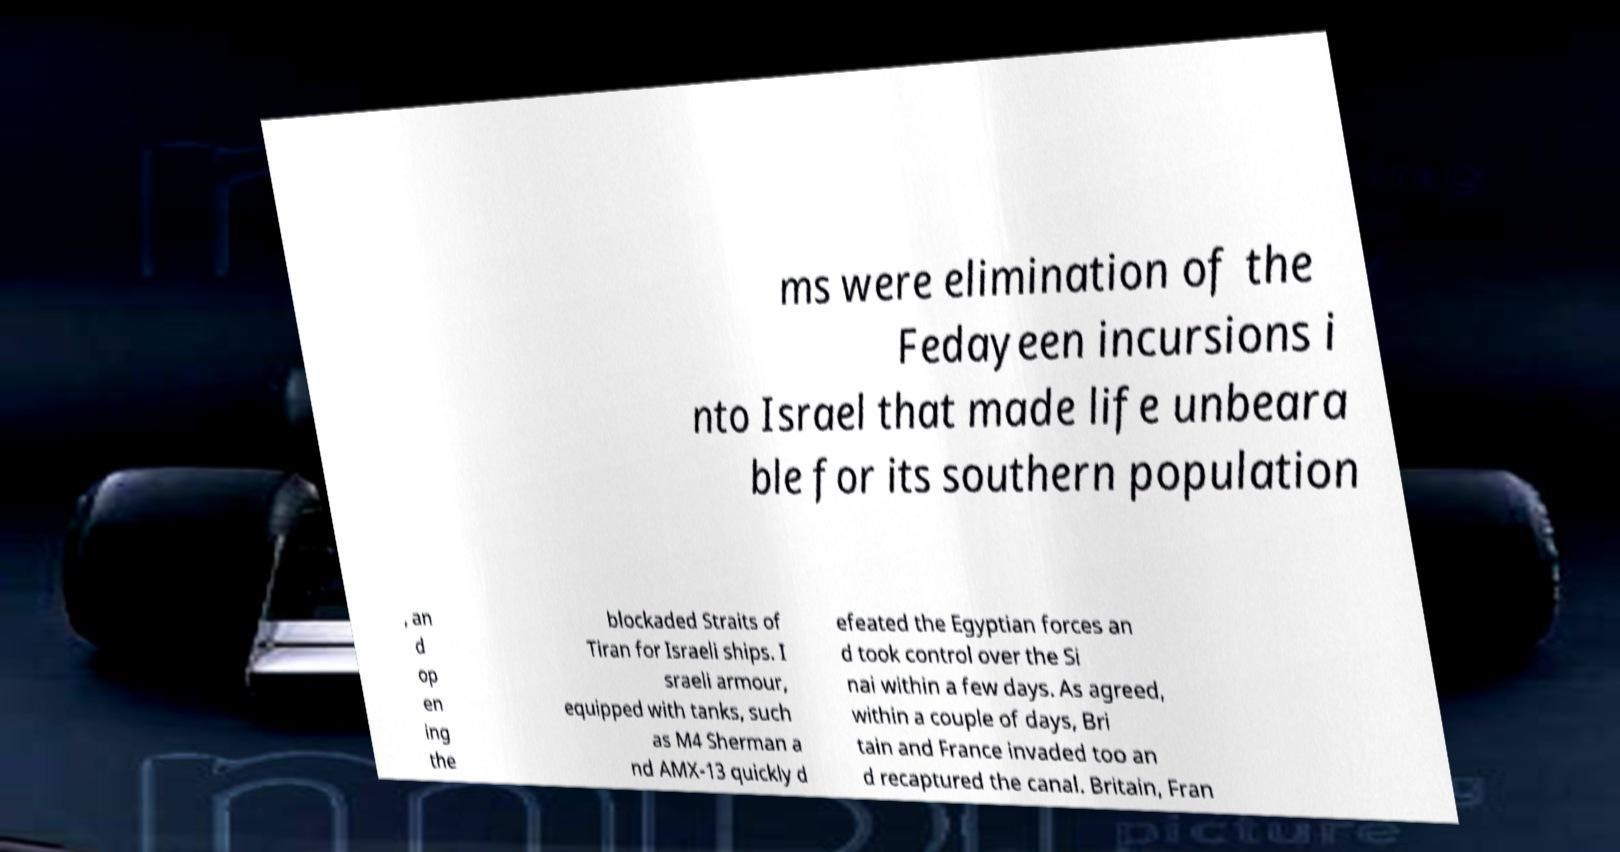What messages or text are displayed in this image? I need them in a readable, typed format. ms were elimination of the Fedayeen incursions i nto Israel that made life unbeara ble for its southern population , an d op en ing the blockaded Straits of Tiran for Israeli ships. I sraeli armour, equipped with tanks, such as M4 Sherman a nd AMX-13 quickly d efeated the Egyptian forces an d took control over the Si nai within a few days. As agreed, within a couple of days, Bri tain and France invaded too an d recaptured the canal. Britain, Fran 